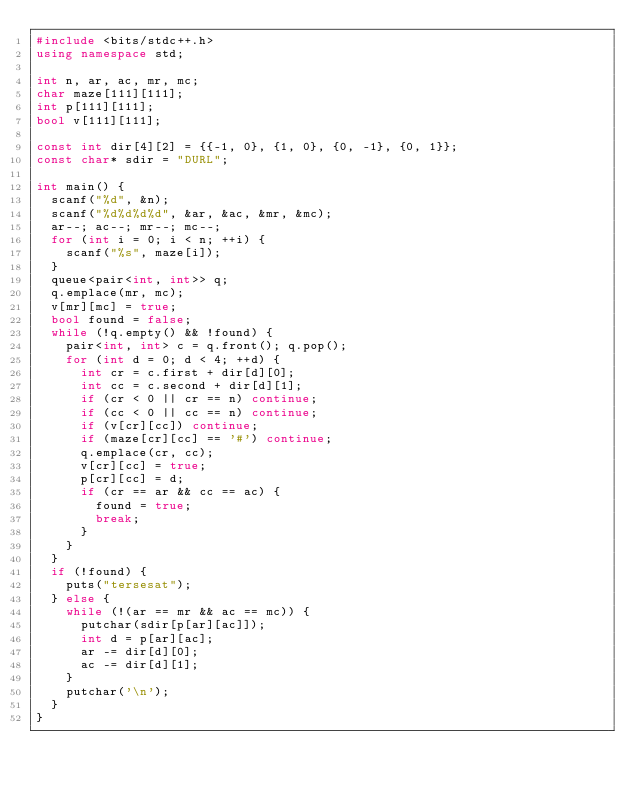Convert code to text. <code><loc_0><loc_0><loc_500><loc_500><_C++_>#include <bits/stdc++.h>
using namespace std;

int n, ar, ac, mr, mc;
char maze[111][111];
int p[111][111];
bool v[111][111];

const int dir[4][2] = {{-1, 0}, {1, 0}, {0, -1}, {0, 1}};
const char* sdir = "DURL";

int main() {
  scanf("%d", &n);
  scanf("%d%d%d%d", &ar, &ac, &mr, &mc);
  ar--; ac--; mr--; mc--;
  for (int i = 0; i < n; ++i) {
    scanf("%s", maze[i]);
  }
  queue<pair<int, int>> q;
  q.emplace(mr, mc);
  v[mr][mc] = true;
  bool found = false;
  while (!q.empty() && !found) {
    pair<int, int> c = q.front(); q.pop();
    for (int d = 0; d < 4; ++d) {
      int cr = c.first + dir[d][0];
      int cc = c.second + dir[d][1];
      if (cr < 0 || cr == n) continue;
      if (cc < 0 || cc == n) continue;
      if (v[cr][cc]) continue;
      if (maze[cr][cc] == '#') continue;
      q.emplace(cr, cc);
      v[cr][cc] = true;
      p[cr][cc] = d;
      if (cr == ar && cc == ac) {
        found = true;
        break;
      }
    }
  }
  if (!found) {
    puts("tersesat");
  } else {
    while (!(ar == mr && ac == mc)) {
      putchar(sdir[p[ar][ac]]);
      int d = p[ar][ac];
      ar -= dir[d][0];
      ac -= dir[d][1];
    }
    putchar('\n');
  }
}</code> 